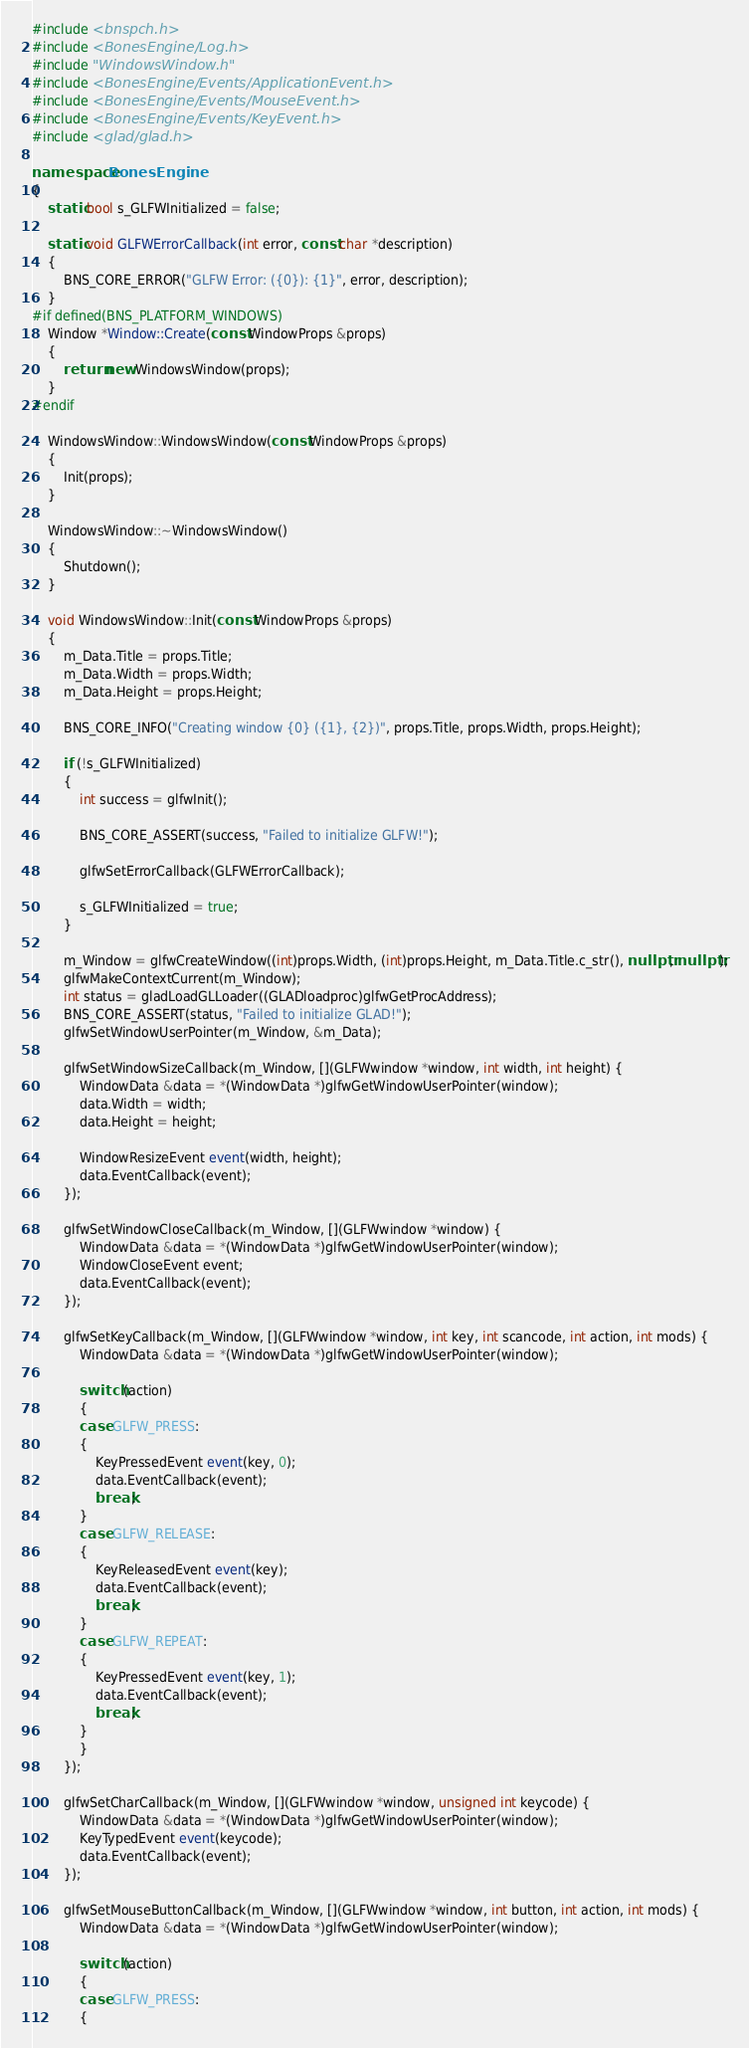<code> <loc_0><loc_0><loc_500><loc_500><_C++_>#include <bnspch.h>
#include <BonesEngine/Log.h>
#include "WindowsWindow.h"
#include <BonesEngine/Events/ApplicationEvent.h>
#include <BonesEngine/Events/MouseEvent.h>
#include <BonesEngine/Events/KeyEvent.h>
#include <glad/glad.h>

namespace BonesEngine
{
	static bool s_GLFWInitialized = false;

	static void GLFWErrorCallback(int error, const char *description)
	{
		BNS_CORE_ERROR("GLFW Error: ({0}): {1}", error, description);
	}
#if defined(BNS_PLATFORM_WINDOWS)
	Window *Window::Create(const WindowProps &props)
	{
		return new WindowsWindow(props);
	}
#endif

	WindowsWindow::WindowsWindow(const WindowProps &props)
	{
		Init(props);
	}

	WindowsWindow::~WindowsWindow()
	{
		Shutdown();
	}

	void WindowsWindow::Init(const WindowProps &props)
	{
		m_Data.Title = props.Title;
		m_Data.Width = props.Width;
		m_Data.Height = props.Height;

		BNS_CORE_INFO("Creating window {0} ({1}, {2})", props.Title, props.Width, props.Height);

		if (!s_GLFWInitialized)
		{
			int success = glfwInit();

			BNS_CORE_ASSERT(success, "Failed to initialize GLFW!");

			glfwSetErrorCallback(GLFWErrorCallback);

			s_GLFWInitialized = true;
		}

		m_Window = glfwCreateWindow((int)props.Width, (int)props.Height, m_Data.Title.c_str(), nullptr, nullptr);
		glfwMakeContextCurrent(m_Window);
		int status = gladLoadGLLoader((GLADloadproc)glfwGetProcAddress);
		BNS_CORE_ASSERT(status, "Failed to initialize GLAD!");
		glfwSetWindowUserPointer(m_Window, &m_Data);

		glfwSetWindowSizeCallback(m_Window, [](GLFWwindow *window, int width, int height) {
			WindowData &data = *(WindowData *)glfwGetWindowUserPointer(window);
			data.Width = width;
			data.Height = height;

			WindowResizeEvent event(width, height);
			data.EventCallback(event);
		});

		glfwSetWindowCloseCallback(m_Window, [](GLFWwindow *window) {
			WindowData &data = *(WindowData *)glfwGetWindowUserPointer(window);
			WindowCloseEvent event;
			data.EventCallback(event);
		});

		glfwSetKeyCallback(m_Window, [](GLFWwindow *window, int key, int scancode, int action, int mods) {
			WindowData &data = *(WindowData *)glfwGetWindowUserPointer(window);

			switch (action)
			{
			case GLFW_PRESS:
			{
				KeyPressedEvent event(key, 0);
				data.EventCallback(event);
				break;
			}
			case GLFW_RELEASE:
			{
				KeyReleasedEvent event(key);
				data.EventCallback(event);
				break;
			}
			case GLFW_REPEAT:
			{
				KeyPressedEvent event(key, 1);
				data.EventCallback(event);
				break;
			}
			}
		});

		glfwSetCharCallback(m_Window, [](GLFWwindow *window, unsigned int keycode) {
			WindowData &data = *(WindowData *)glfwGetWindowUserPointer(window);
			KeyTypedEvent event(keycode);
			data.EventCallback(event);
		});

		glfwSetMouseButtonCallback(m_Window, [](GLFWwindow *window, int button, int action, int mods) {
			WindowData &data = *(WindowData *)glfwGetWindowUserPointer(window);

			switch (action)
			{
			case GLFW_PRESS:
			{</code> 